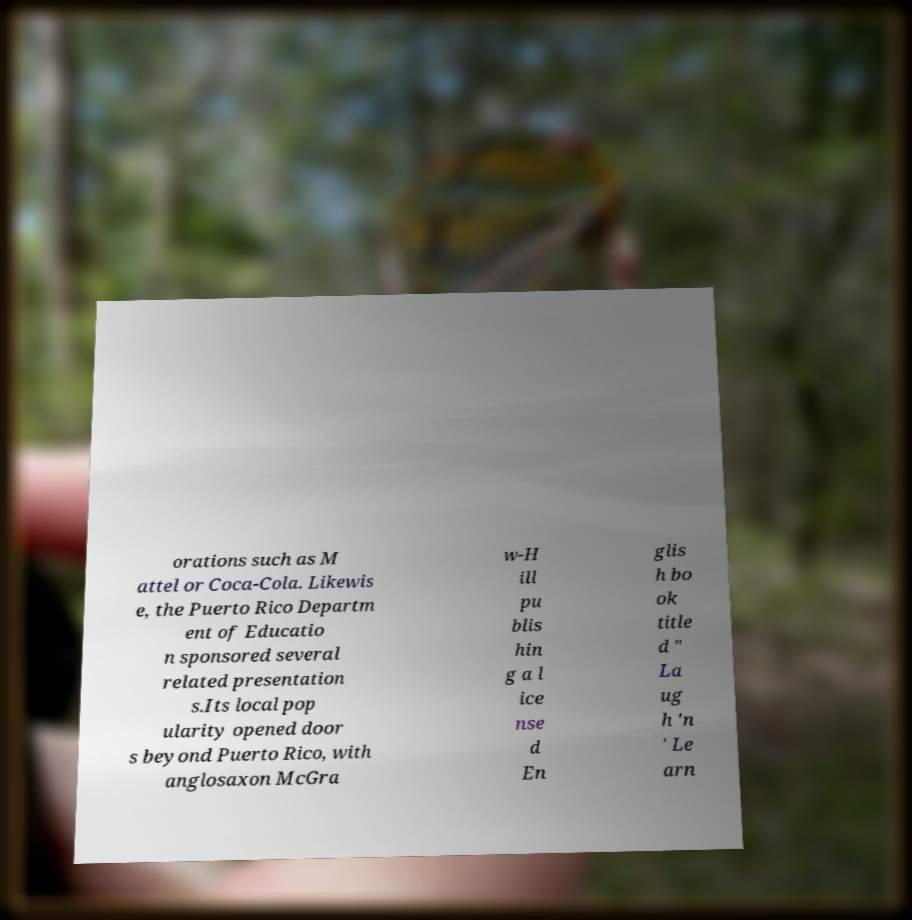Please read and relay the text visible in this image. What does it say? orations such as M attel or Coca-Cola. Likewis e, the Puerto Rico Departm ent of Educatio n sponsored several related presentation s.Its local pop ularity opened door s beyond Puerto Rico, with anglosaxon McGra w-H ill pu blis hin g a l ice nse d En glis h bo ok title d " La ug h 'n ' Le arn 